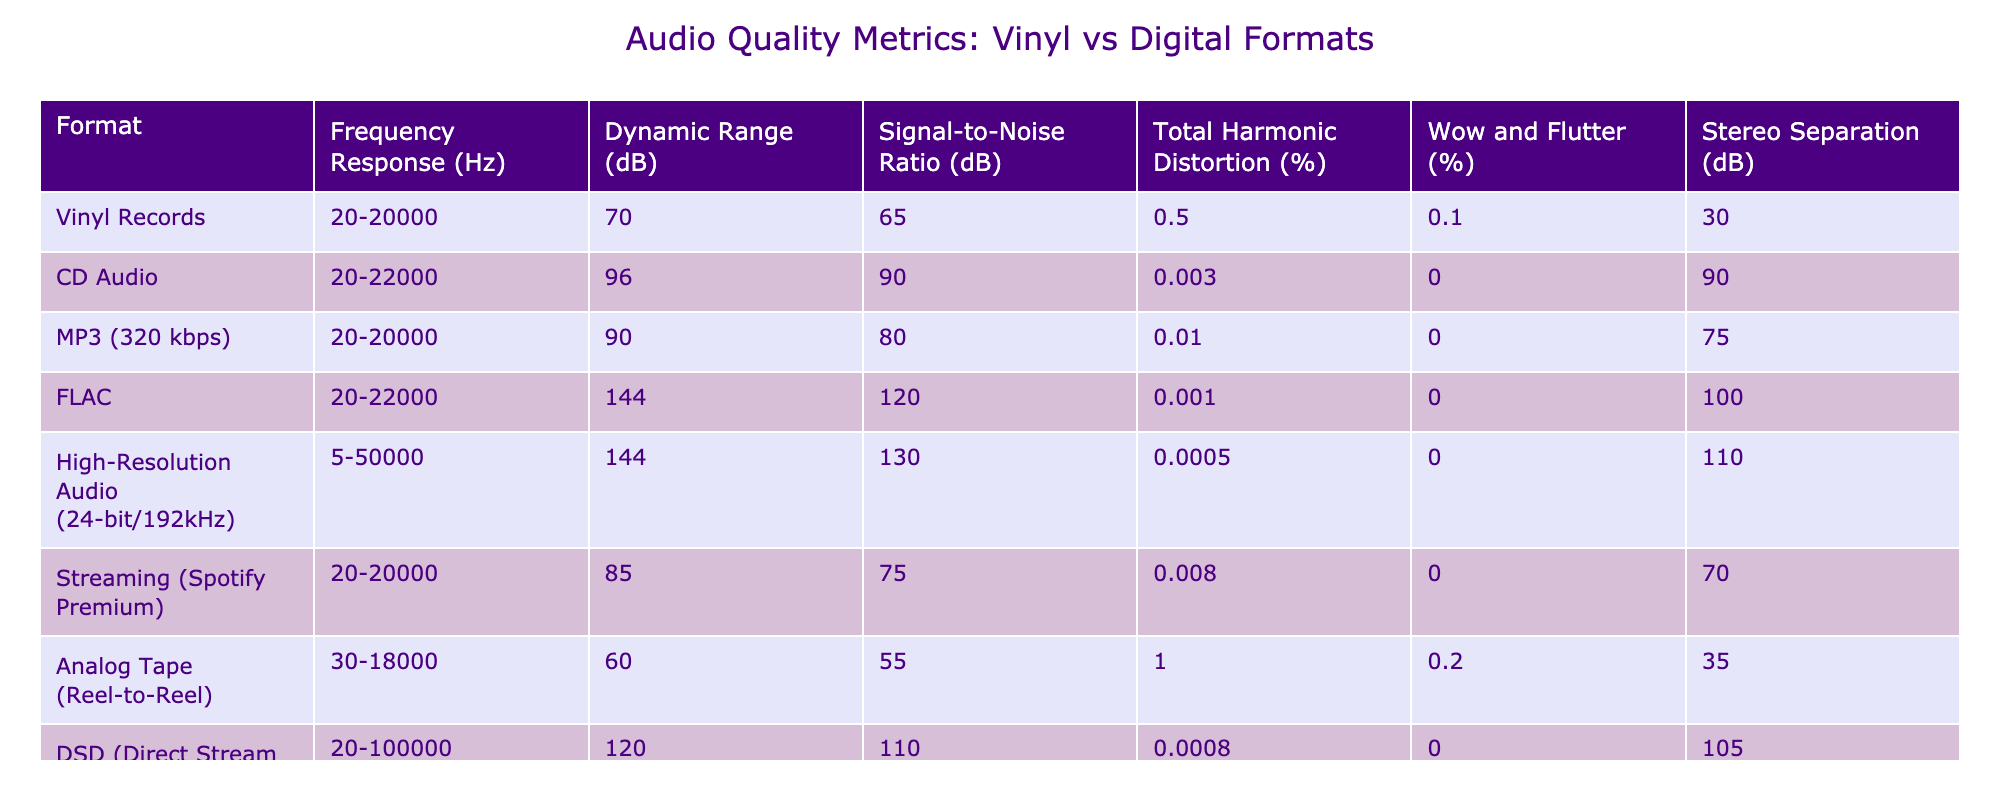What is the dynamic range of Vinyl Records? Looking at the table, under the column "Dynamic Range (dB)", the value corresponding to Vinyl Records is 70 dB.
Answer: 70 dB Which audio format has the highest signal-to-noise ratio? By comparing the "Signal-to-Noise Ratio (dB)" values for each format, the one with the highest value is FLAC, which has a ratio of 120 dB.
Answer: FLAC What is the total harmonic distortion percentage for CD Audio? The table shows that the "Total Harmonic Distortion (%)" for CD Audio is 0.003%.
Answer: 0.003% Is the frequency response range for High-Resolution Audio wider than that of Vinyl Records? The frequency response for High-Resolution Audio is 5-50000 Hz, which is wider than the 20-20000 Hz range of Vinyl Records.
Answer: Yes What is the average dynamic range of digital audio formats (CD, MP3, FLAC, High-Resolution Audio, Streaming, DSD)? The dynamic ranges for the digital formats listed are: CD (96), MP3 (90), FLAC (144), High-Resolution (144), Streaming (85), DSD (120). Summing these gives: 96 + 90 + 144 + 144 + 85 + 120 = 679. The average is 679 divided by 6, which equals approximately 113.17.
Answer: 113.17 dB Which format has the lowest wow and flutter percentage? Comparing the "Wow and Flutter (%)" column, CD Audio, MP3, FLAC, High-Resolution Audio, and Streaming formats all have 0%. Therefore, these formats share the lowest wow and flutter percentage.
Answer: CD Audio, MP3, FLAC, High-Resolution Audio, Streaming (0%) What is the difference in dynamic range between High-Resolution Audio and Vinyl Records? The dynamic range of High-Resolution Audio is 144 dB, while that of Vinyl Records is 70 dB. The difference is 144 - 70 = 74 dB.
Answer: 74 dB Which formats have a stereo separation greater than 75 dB? From the "Stereo Separation (dB)" column, CD Audio (90), FLAC (100), High-Resolution Audio (110), and DSD (105) all exceed 75 dB.
Answer: CD Audio, FLAC, High-Resolution Audio, DSD What is the total harmonic distortion for the formats that have a signal-to-noise ratio of 80 dB or above? The formats with a signal-to-noise ratio of 80 dB or higher are CD Audio (0.003%), MP3 (0.01%), FLAC (0.001%), High-Resolution Audio (0.0005%), and DSD (0.0008%). Summing the distortions gives: 0.003 + 0.01 + 0.001 + 0.0005 + 0.0008 = 0.0153%.
Answer: 0.0153% Is it true that Analog Tape has both the lowest dynamic range and highest total harmonic distortion? Checking the table, Analog Tape has a dynamic range of 60 dB (the lowest) and a total harmonic distortion of 1% (the highest), confirming the statement is true.
Answer: Yes 